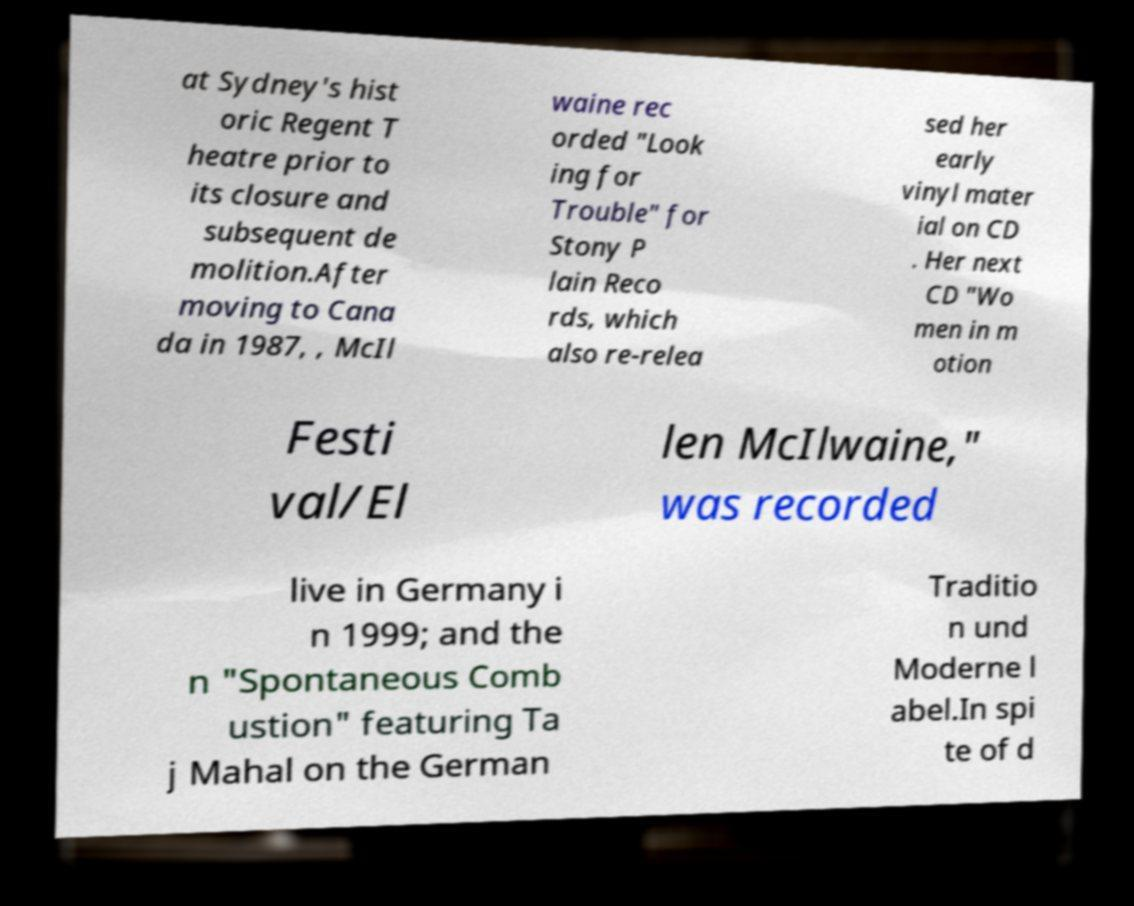Could you assist in decoding the text presented in this image and type it out clearly? at Sydney's hist oric Regent T heatre prior to its closure and subsequent de molition.After moving to Cana da in 1987, , McIl waine rec orded "Look ing for Trouble" for Stony P lain Reco rds, which also re-relea sed her early vinyl mater ial on CD . Her next CD "Wo men in m otion Festi val/El len McIlwaine," was recorded live in Germany i n 1999; and the n "Spontaneous Comb ustion" featuring Ta j Mahal on the German Traditio n und Moderne l abel.In spi te of d 